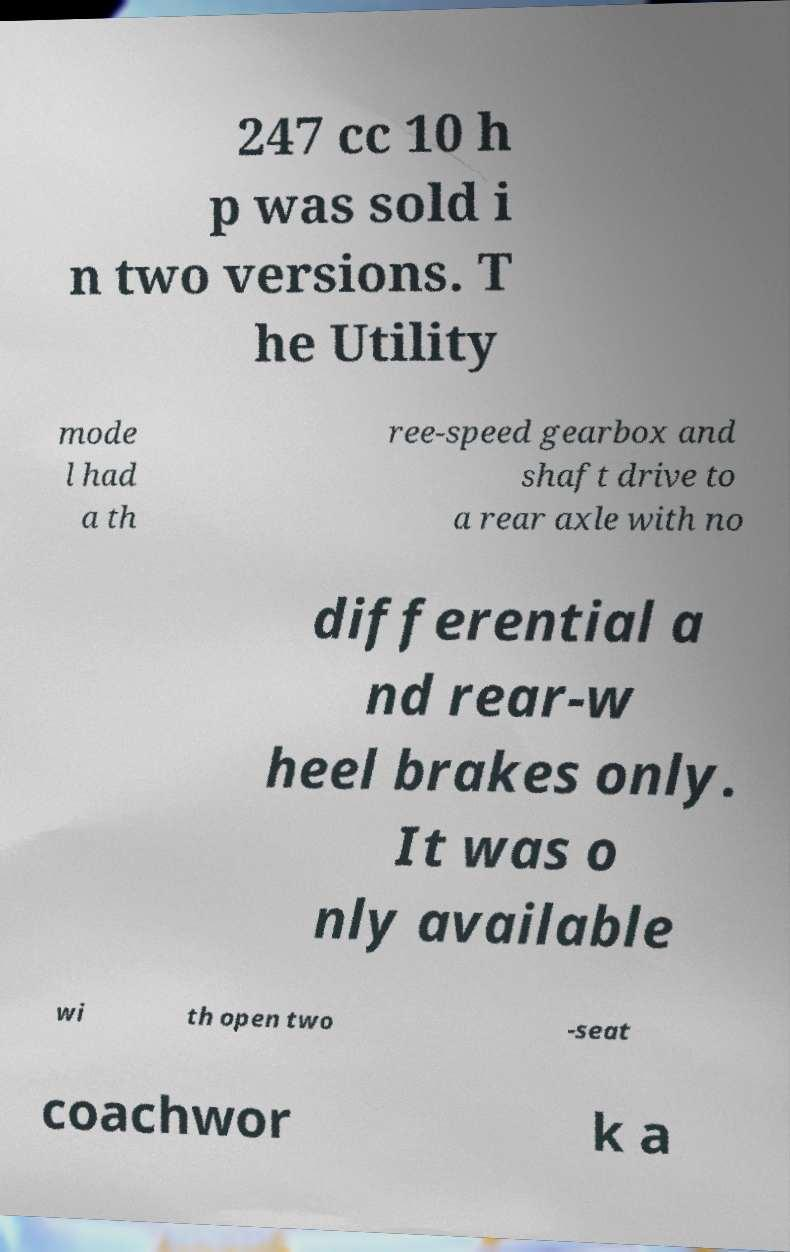Can you read and provide the text displayed in the image?This photo seems to have some interesting text. Can you extract and type it out for me? 247 cc 10 h p was sold i n two versions. T he Utility mode l had a th ree-speed gearbox and shaft drive to a rear axle with no differential a nd rear-w heel brakes only. It was o nly available wi th open two -seat coachwor k a 